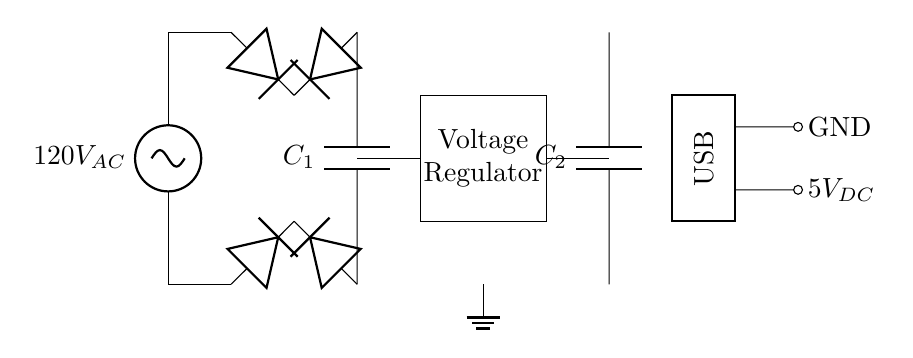What is the input voltage of the circuit? The input voltage is labeled as 120V AC, which is the voltage supplied to the entire circuit.
Answer: 120V AC What component smooths the output voltage? The smoothing capacitor, denoted as C1, is used to smooth out the voltage after rectification, reducing fluctuations in the output voltage.
Answer: C1 How many diodes are used in the bridge rectifier? There are four diodes used in the bridge rectifier section, as shown connecting the AC input to the positive and negative outputs.
Answer: Four What is the output voltage of the circuit? The output voltage is specified as 5V DC, which is the regulated voltage supplied to the USB interface.
Answer: 5V DC What does the rectangular shape labeled "Voltage Regulator" do? The voltage regulator converts the rectified and smoothed voltage to a consistent output voltage, in this case, maintaining it at 5V DC for the USB output.
Answer: Regulates voltage What happens to the waveform of the AC input after passing through the bridge rectifier? After passing through the bridge rectifier, the AC waveform becomes pulsating DC, and the smoothing capacitor further smooths this output.
Answer: Becomes pulsating DC What type of connection does the circuit provide for USB devices? The circuit provides a standard USB connection, allowing devices to connect and receive the regulated 5V DC output along with ground.
Answer: USB connection 